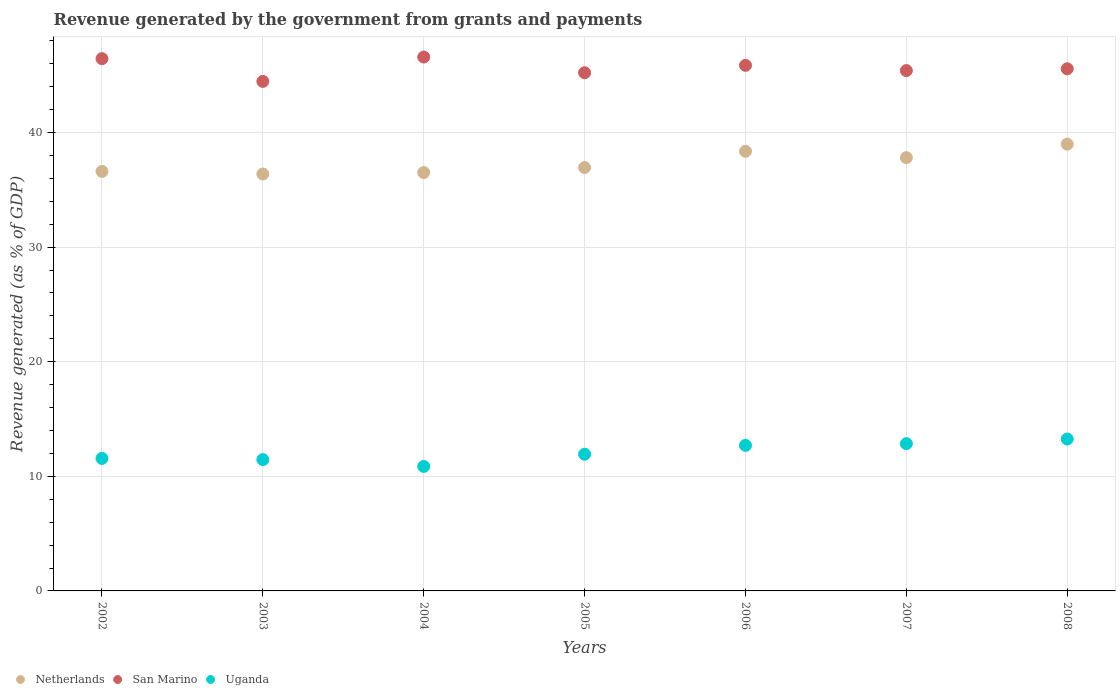How many different coloured dotlines are there?
Provide a short and direct response. 3. What is the revenue generated by the government in Netherlands in 2006?
Your response must be concise. 38.36. Across all years, what is the maximum revenue generated by the government in Netherlands?
Offer a terse response. 38.99. Across all years, what is the minimum revenue generated by the government in San Marino?
Your answer should be very brief. 44.46. In which year was the revenue generated by the government in San Marino minimum?
Make the answer very short. 2003. What is the total revenue generated by the government in San Marino in the graph?
Ensure brevity in your answer.  319.54. What is the difference between the revenue generated by the government in Netherlands in 2004 and that in 2006?
Provide a succinct answer. -1.86. What is the difference between the revenue generated by the government in San Marino in 2004 and the revenue generated by the government in Uganda in 2003?
Your response must be concise. 35.13. What is the average revenue generated by the government in San Marino per year?
Keep it short and to the point. 45.65. In the year 2004, what is the difference between the revenue generated by the government in Uganda and revenue generated by the government in Netherlands?
Keep it short and to the point. -25.64. In how many years, is the revenue generated by the government in Netherlands greater than 6 %?
Ensure brevity in your answer.  7. What is the ratio of the revenue generated by the government in Netherlands in 2004 to that in 2005?
Provide a short and direct response. 0.99. Is the revenue generated by the government in Uganda in 2004 less than that in 2007?
Give a very brief answer. Yes. What is the difference between the highest and the second highest revenue generated by the government in Uganda?
Provide a short and direct response. 0.4. What is the difference between the highest and the lowest revenue generated by the government in Netherlands?
Your answer should be compact. 2.61. In how many years, is the revenue generated by the government in Uganda greater than the average revenue generated by the government in Uganda taken over all years?
Provide a succinct answer. 3. Is the sum of the revenue generated by the government in San Marino in 2003 and 2007 greater than the maximum revenue generated by the government in Uganda across all years?
Your answer should be very brief. Yes. Is the revenue generated by the government in Netherlands strictly greater than the revenue generated by the government in San Marino over the years?
Make the answer very short. No. Does the graph contain any zero values?
Keep it short and to the point. No. Where does the legend appear in the graph?
Give a very brief answer. Bottom left. How many legend labels are there?
Keep it short and to the point. 3. What is the title of the graph?
Keep it short and to the point. Revenue generated by the government from grants and payments. Does "Bhutan" appear as one of the legend labels in the graph?
Keep it short and to the point. No. What is the label or title of the X-axis?
Your response must be concise. Years. What is the label or title of the Y-axis?
Offer a terse response. Revenue generated (as % of GDP). What is the Revenue generated (as % of GDP) of Netherlands in 2002?
Make the answer very short. 36.61. What is the Revenue generated (as % of GDP) in San Marino in 2002?
Offer a terse response. 46.45. What is the Revenue generated (as % of GDP) of Uganda in 2002?
Give a very brief answer. 11.56. What is the Revenue generated (as % of GDP) of Netherlands in 2003?
Offer a very short reply. 36.38. What is the Revenue generated (as % of GDP) of San Marino in 2003?
Keep it short and to the point. 44.46. What is the Revenue generated (as % of GDP) of Uganda in 2003?
Give a very brief answer. 11.46. What is the Revenue generated (as % of GDP) of Netherlands in 2004?
Your answer should be compact. 36.51. What is the Revenue generated (as % of GDP) in San Marino in 2004?
Offer a terse response. 46.59. What is the Revenue generated (as % of GDP) of Uganda in 2004?
Offer a terse response. 10.87. What is the Revenue generated (as % of GDP) of Netherlands in 2005?
Ensure brevity in your answer.  36.95. What is the Revenue generated (as % of GDP) in San Marino in 2005?
Your response must be concise. 45.22. What is the Revenue generated (as % of GDP) in Uganda in 2005?
Offer a very short reply. 11.93. What is the Revenue generated (as % of GDP) of Netherlands in 2006?
Your answer should be compact. 38.36. What is the Revenue generated (as % of GDP) in San Marino in 2006?
Make the answer very short. 45.86. What is the Revenue generated (as % of GDP) of Uganda in 2006?
Your answer should be very brief. 12.7. What is the Revenue generated (as % of GDP) in Netherlands in 2007?
Make the answer very short. 37.81. What is the Revenue generated (as % of GDP) of San Marino in 2007?
Provide a short and direct response. 45.4. What is the Revenue generated (as % of GDP) of Uganda in 2007?
Keep it short and to the point. 12.85. What is the Revenue generated (as % of GDP) in Netherlands in 2008?
Ensure brevity in your answer.  38.99. What is the Revenue generated (as % of GDP) in San Marino in 2008?
Your answer should be very brief. 45.56. What is the Revenue generated (as % of GDP) in Uganda in 2008?
Your answer should be compact. 13.25. Across all years, what is the maximum Revenue generated (as % of GDP) of Netherlands?
Provide a succinct answer. 38.99. Across all years, what is the maximum Revenue generated (as % of GDP) in San Marino?
Offer a very short reply. 46.59. Across all years, what is the maximum Revenue generated (as % of GDP) of Uganda?
Offer a very short reply. 13.25. Across all years, what is the minimum Revenue generated (as % of GDP) of Netherlands?
Provide a short and direct response. 36.38. Across all years, what is the minimum Revenue generated (as % of GDP) in San Marino?
Give a very brief answer. 44.46. Across all years, what is the minimum Revenue generated (as % of GDP) of Uganda?
Keep it short and to the point. 10.87. What is the total Revenue generated (as % of GDP) in Netherlands in the graph?
Make the answer very short. 261.6. What is the total Revenue generated (as % of GDP) of San Marino in the graph?
Ensure brevity in your answer.  319.54. What is the total Revenue generated (as % of GDP) of Uganda in the graph?
Provide a succinct answer. 84.62. What is the difference between the Revenue generated (as % of GDP) in Netherlands in 2002 and that in 2003?
Keep it short and to the point. 0.23. What is the difference between the Revenue generated (as % of GDP) in San Marino in 2002 and that in 2003?
Provide a succinct answer. 1.98. What is the difference between the Revenue generated (as % of GDP) in Uganda in 2002 and that in 2003?
Your answer should be very brief. 0.1. What is the difference between the Revenue generated (as % of GDP) in Netherlands in 2002 and that in 2004?
Provide a succinct answer. 0.1. What is the difference between the Revenue generated (as % of GDP) of San Marino in 2002 and that in 2004?
Offer a very short reply. -0.14. What is the difference between the Revenue generated (as % of GDP) of Uganda in 2002 and that in 2004?
Provide a succinct answer. 0.7. What is the difference between the Revenue generated (as % of GDP) of Netherlands in 2002 and that in 2005?
Offer a very short reply. -0.34. What is the difference between the Revenue generated (as % of GDP) in San Marino in 2002 and that in 2005?
Keep it short and to the point. 1.23. What is the difference between the Revenue generated (as % of GDP) of Uganda in 2002 and that in 2005?
Offer a terse response. -0.36. What is the difference between the Revenue generated (as % of GDP) of Netherlands in 2002 and that in 2006?
Keep it short and to the point. -1.75. What is the difference between the Revenue generated (as % of GDP) of San Marino in 2002 and that in 2006?
Your answer should be compact. 0.58. What is the difference between the Revenue generated (as % of GDP) of Uganda in 2002 and that in 2006?
Give a very brief answer. -1.14. What is the difference between the Revenue generated (as % of GDP) of Netherlands in 2002 and that in 2007?
Make the answer very short. -1.2. What is the difference between the Revenue generated (as % of GDP) of San Marino in 2002 and that in 2007?
Offer a very short reply. 1.04. What is the difference between the Revenue generated (as % of GDP) in Uganda in 2002 and that in 2007?
Offer a terse response. -1.29. What is the difference between the Revenue generated (as % of GDP) of Netherlands in 2002 and that in 2008?
Provide a succinct answer. -2.38. What is the difference between the Revenue generated (as % of GDP) in San Marino in 2002 and that in 2008?
Provide a short and direct response. 0.89. What is the difference between the Revenue generated (as % of GDP) of Uganda in 2002 and that in 2008?
Provide a succinct answer. -1.69. What is the difference between the Revenue generated (as % of GDP) in Netherlands in 2003 and that in 2004?
Make the answer very short. -0.13. What is the difference between the Revenue generated (as % of GDP) of San Marino in 2003 and that in 2004?
Offer a very short reply. -2.12. What is the difference between the Revenue generated (as % of GDP) in Uganda in 2003 and that in 2004?
Provide a succinct answer. 0.59. What is the difference between the Revenue generated (as % of GDP) in Netherlands in 2003 and that in 2005?
Your answer should be very brief. -0.57. What is the difference between the Revenue generated (as % of GDP) of San Marino in 2003 and that in 2005?
Your answer should be compact. -0.76. What is the difference between the Revenue generated (as % of GDP) in Uganda in 2003 and that in 2005?
Ensure brevity in your answer.  -0.47. What is the difference between the Revenue generated (as % of GDP) in Netherlands in 2003 and that in 2006?
Offer a very short reply. -1.98. What is the difference between the Revenue generated (as % of GDP) in San Marino in 2003 and that in 2006?
Offer a terse response. -1.4. What is the difference between the Revenue generated (as % of GDP) in Uganda in 2003 and that in 2006?
Ensure brevity in your answer.  -1.24. What is the difference between the Revenue generated (as % of GDP) of Netherlands in 2003 and that in 2007?
Your answer should be compact. -1.43. What is the difference between the Revenue generated (as % of GDP) of San Marino in 2003 and that in 2007?
Your answer should be very brief. -0.94. What is the difference between the Revenue generated (as % of GDP) in Uganda in 2003 and that in 2007?
Your response must be concise. -1.39. What is the difference between the Revenue generated (as % of GDP) of Netherlands in 2003 and that in 2008?
Provide a short and direct response. -2.61. What is the difference between the Revenue generated (as % of GDP) in San Marino in 2003 and that in 2008?
Your response must be concise. -1.1. What is the difference between the Revenue generated (as % of GDP) of Uganda in 2003 and that in 2008?
Make the answer very short. -1.79. What is the difference between the Revenue generated (as % of GDP) in Netherlands in 2004 and that in 2005?
Give a very brief answer. -0.44. What is the difference between the Revenue generated (as % of GDP) in San Marino in 2004 and that in 2005?
Provide a short and direct response. 1.37. What is the difference between the Revenue generated (as % of GDP) of Uganda in 2004 and that in 2005?
Your answer should be compact. -1.06. What is the difference between the Revenue generated (as % of GDP) in Netherlands in 2004 and that in 2006?
Provide a short and direct response. -1.86. What is the difference between the Revenue generated (as % of GDP) of San Marino in 2004 and that in 2006?
Your answer should be very brief. 0.72. What is the difference between the Revenue generated (as % of GDP) in Uganda in 2004 and that in 2006?
Ensure brevity in your answer.  -1.84. What is the difference between the Revenue generated (as % of GDP) in Netherlands in 2004 and that in 2007?
Give a very brief answer. -1.3. What is the difference between the Revenue generated (as % of GDP) in San Marino in 2004 and that in 2007?
Make the answer very short. 1.18. What is the difference between the Revenue generated (as % of GDP) of Uganda in 2004 and that in 2007?
Keep it short and to the point. -1.98. What is the difference between the Revenue generated (as % of GDP) in Netherlands in 2004 and that in 2008?
Make the answer very short. -2.48. What is the difference between the Revenue generated (as % of GDP) in San Marino in 2004 and that in 2008?
Provide a succinct answer. 1.03. What is the difference between the Revenue generated (as % of GDP) of Uganda in 2004 and that in 2008?
Offer a terse response. -2.39. What is the difference between the Revenue generated (as % of GDP) of Netherlands in 2005 and that in 2006?
Make the answer very short. -1.42. What is the difference between the Revenue generated (as % of GDP) of San Marino in 2005 and that in 2006?
Give a very brief answer. -0.64. What is the difference between the Revenue generated (as % of GDP) in Uganda in 2005 and that in 2006?
Offer a terse response. -0.78. What is the difference between the Revenue generated (as % of GDP) in Netherlands in 2005 and that in 2007?
Offer a very short reply. -0.86. What is the difference between the Revenue generated (as % of GDP) in San Marino in 2005 and that in 2007?
Provide a short and direct response. -0.19. What is the difference between the Revenue generated (as % of GDP) in Uganda in 2005 and that in 2007?
Provide a succinct answer. -0.92. What is the difference between the Revenue generated (as % of GDP) in Netherlands in 2005 and that in 2008?
Offer a terse response. -2.04. What is the difference between the Revenue generated (as % of GDP) of San Marino in 2005 and that in 2008?
Your answer should be compact. -0.34. What is the difference between the Revenue generated (as % of GDP) in Uganda in 2005 and that in 2008?
Provide a succinct answer. -1.33. What is the difference between the Revenue generated (as % of GDP) in Netherlands in 2006 and that in 2007?
Ensure brevity in your answer.  0.56. What is the difference between the Revenue generated (as % of GDP) of San Marino in 2006 and that in 2007?
Give a very brief answer. 0.46. What is the difference between the Revenue generated (as % of GDP) of Uganda in 2006 and that in 2007?
Provide a succinct answer. -0.15. What is the difference between the Revenue generated (as % of GDP) in Netherlands in 2006 and that in 2008?
Offer a very short reply. -0.62. What is the difference between the Revenue generated (as % of GDP) in San Marino in 2006 and that in 2008?
Make the answer very short. 0.3. What is the difference between the Revenue generated (as % of GDP) in Uganda in 2006 and that in 2008?
Ensure brevity in your answer.  -0.55. What is the difference between the Revenue generated (as % of GDP) in Netherlands in 2007 and that in 2008?
Offer a terse response. -1.18. What is the difference between the Revenue generated (as % of GDP) of San Marino in 2007 and that in 2008?
Ensure brevity in your answer.  -0.16. What is the difference between the Revenue generated (as % of GDP) of Uganda in 2007 and that in 2008?
Your answer should be compact. -0.4. What is the difference between the Revenue generated (as % of GDP) of Netherlands in 2002 and the Revenue generated (as % of GDP) of San Marino in 2003?
Provide a short and direct response. -7.85. What is the difference between the Revenue generated (as % of GDP) in Netherlands in 2002 and the Revenue generated (as % of GDP) in Uganda in 2003?
Offer a very short reply. 25.15. What is the difference between the Revenue generated (as % of GDP) in San Marino in 2002 and the Revenue generated (as % of GDP) in Uganda in 2003?
Provide a succinct answer. 34.99. What is the difference between the Revenue generated (as % of GDP) in Netherlands in 2002 and the Revenue generated (as % of GDP) in San Marino in 2004?
Provide a short and direct response. -9.98. What is the difference between the Revenue generated (as % of GDP) in Netherlands in 2002 and the Revenue generated (as % of GDP) in Uganda in 2004?
Ensure brevity in your answer.  25.74. What is the difference between the Revenue generated (as % of GDP) in San Marino in 2002 and the Revenue generated (as % of GDP) in Uganda in 2004?
Offer a very short reply. 35.58. What is the difference between the Revenue generated (as % of GDP) of Netherlands in 2002 and the Revenue generated (as % of GDP) of San Marino in 2005?
Your response must be concise. -8.61. What is the difference between the Revenue generated (as % of GDP) of Netherlands in 2002 and the Revenue generated (as % of GDP) of Uganda in 2005?
Keep it short and to the point. 24.68. What is the difference between the Revenue generated (as % of GDP) of San Marino in 2002 and the Revenue generated (as % of GDP) of Uganda in 2005?
Your answer should be very brief. 34.52. What is the difference between the Revenue generated (as % of GDP) of Netherlands in 2002 and the Revenue generated (as % of GDP) of San Marino in 2006?
Your response must be concise. -9.25. What is the difference between the Revenue generated (as % of GDP) of Netherlands in 2002 and the Revenue generated (as % of GDP) of Uganda in 2006?
Your response must be concise. 23.91. What is the difference between the Revenue generated (as % of GDP) in San Marino in 2002 and the Revenue generated (as % of GDP) in Uganda in 2006?
Provide a succinct answer. 33.74. What is the difference between the Revenue generated (as % of GDP) of Netherlands in 2002 and the Revenue generated (as % of GDP) of San Marino in 2007?
Provide a short and direct response. -8.79. What is the difference between the Revenue generated (as % of GDP) of Netherlands in 2002 and the Revenue generated (as % of GDP) of Uganda in 2007?
Keep it short and to the point. 23.76. What is the difference between the Revenue generated (as % of GDP) of San Marino in 2002 and the Revenue generated (as % of GDP) of Uganda in 2007?
Make the answer very short. 33.6. What is the difference between the Revenue generated (as % of GDP) of Netherlands in 2002 and the Revenue generated (as % of GDP) of San Marino in 2008?
Ensure brevity in your answer.  -8.95. What is the difference between the Revenue generated (as % of GDP) of Netherlands in 2002 and the Revenue generated (as % of GDP) of Uganda in 2008?
Keep it short and to the point. 23.36. What is the difference between the Revenue generated (as % of GDP) in San Marino in 2002 and the Revenue generated (as % of GDP) in Uganda in 2008?
Ensure brevity in your answer.  33.19. What is the difference between the Revenue generated (as % of GDP) in Netherlands in 2003 and the Revenue generated (as % of GDP) in San Marino in 2004?
Your answer should be very brief. -10.21. What is the difference between the Revenue generated (as % of GDP) of Netherlands in 2003 and the Revenue generated (as % of GDP) of Uganda in 2004?
Make the answer very short. 25.51. What is the difference between the Revenue generated (as % of GDP) in San Marino in 2003 and the Revenue generated (as % of GDP) in Uganda in 2004?
Provide a short and direct response. 33.6. What is the difference between the Revenue generated (as % of GDP) of Netherlands in 2003 and the Revenue generated (as % of GDP) of San Marino in 2005?
Keep it short and to the point. -8.84. What is the difference between the Revenue generated (as % of GDP) in Netherlands in 2003 and the Revenue generated (as % of GDP) in Uganda in 2005?
Your answer should be compact. 24.45. What is the difference between the Revenue generated (as % of GDP) of San Marino in 2003 and the Revenue generated (as % of GDP) of Uganda in 2005?
Ensure brevity in your answer.  32.54. What is the difference between the Revenue generated (as % of GDP) of Netherlands in 2003 and the Revenue generated (as % of GDP) of San Marino in 2006?
Make the answer very short. -9.48. What is the difference between the Revenue generated (as % of GDP) of Netherlands in 2003 and the Revenue generated (as % of GDP) of Uganda in 2006?
Offer a terse response. 23.68. What is the difference between the Revenue generated (as % of GDP) in San Marino in 2003 and the Revenue generated (as % of GDP) in Uganda in 2006?
Keep it short and to the point. 31.76. What is the difference between the Revenue generated (as % of GDP) in Netherlands in 2003 and the Revenue generated (as % of GDP) in San Marino in 2007?
Ensure brevity in your answer.  -9.02. What is the difference between the Revenue generated (as % of GDP) of Netherlands in 2003 and the Revenue generated (as % of GDP) of Uganda in 2007?
Offer a terse response. 23.53. What is the difference between the Revenue generated (as % of GDP) in San Marino in 2003 and the Revenue generated (as % of GDP) in Uganda in 2007?
Your answer should be very brief. 31.61. What is the difference between the Revenue generated (as % of GDP) in Netherlands in 2003 and the Revenue generated (as % of GDP) in San Marino in 2008?
Offer a very short reply. -9.18. What is the difference between the Revenue generated (as % of GDP) of Netherlands in 2003 and the Revenue generated (as % of GDP) of Uganda in 2008?
Ensure brevity in your answer.  23.13. What is the difference between the Revenue generated (as % of GDP) of San Marino in 2003 and the Revenue generated (as % of GDP) of Uganda in 2008?
Give a very brief answer. 31.21. What is the difference between the Revenue generated (as % of GDP) of Netherlands in 2004 and the Revenue generated (as % of GDP) of San Marino in 2005?
Provide a succinct answer. -8.71. What is the difference between the Revenue generated (as % of GDP) in Netherlands in 2004 and the Revenue generated (as % of GDP) in Uganda in 2005?
Offer a very short reply. 24.58. What is the difference between the Revenue generated (as % of GDP) in San Marino in 2004 and the Revenue generated (as % of GDP) in Uganda in 2005?
Give a very brief answer. 34.66. What is the difference between the Revenue generated (as % of GDP) in Netherlands in 2004 and the Revenue generated (as % of GDP) in San Marino in 2006?
Offer a terse response. -9.36. What is the difference between the Revenue generated (as % of GDP) in Netherlands in 2004 and the Revenue generated (as % of GDP) in Uganda in 2006?
Your answer should be very brief. 23.8. What is the difference between the Revenue generated (as % of GDP) in San Marino in 2004 and the Revenue generated (as % of GDP) in Uganda in 2006?
Offer a terse response. 33.88. What is the difference between the Revenue generated (as % of GDP) in Netherlands in 2004 and the Revenue generated (as % of GDP) in San Marino in 2007?
Make the answer very short. -8.9. What is the difference between the Revenue generated (as % of GDP) of Netherlands in 2004 and the Revenue generated (as % of GDP) of Uganda in 2007?
Make the answer very short. 23.66. What is the difference between the Revenue generated (as % of GDP) in San Marino in 2004 and the Revenue generated (as % of GDP) in Uganda in 2007?
Make the answer very short. 33.74. What is the difference between the Revenue generated (as % of GDP) in Netherlands in 2004 and the Revenue generated (as % of GDP) in San Marino in 2008?
Provide a succinct answer. -9.05. What is the difference between the Revenue generated (as % of GDP) of Netherlands in 2004 and the Revenue generated (as % of GDP) of Uganda in 2008?
Keep it short and to the point. 23.25. What is the difference between the Revenue generated (as % of GDP) of San Marino in 2004 and the Revenue generated (as % of GDP) of Uganda in 2008?
Give a very brief answer. 33.33. What is the difference between the Revenue generated (as % of GDP) of Netherlands in 2005 and the Revenue generated (as % of GDP) of San Marino in 2006?
Ensure brevity in your answer.  -8.92. What is the difference between the Revenue generated (as % of GDP) of Netherlands in 2005 and the Revenue generated (as % of GDP) of Uganda in 2006?
Offer a terse response. 24.24. What is the difference between the Revenue generated (as % of GDP) of San Marino in 2005 and the Revenue generated (as % of GDP) of Uganda in 2006?
Your answer should be compact. 32.52. What is the difference between the Revenue generated (as % of GDP) in Netherlands in 2005 and the Revenue generated (as % of GDP) in San Marino in 2007?
Make the answer very short. -8.46. What is the difference between the Revenue generated (as % of GDP) of Netherlands in 2005 and the Revenue generated (as % of GDP) of Uganda in 2007?
Your answer should be compact. 24.1. What is the difference between the Revenue generated (as % of GDP) of San Marino in 2005 and the Revenue generated (as % of GDP) of Uganda in 2007?
Offer a terse response. 32.37. What is the difference between the Revenue generated (as % of GDP) of Netherlands in 2005 and the Revenue generated (as % of GDP) of San Marino in 2008?
Provide a short and direct response. -8.61. What is the difference between the Revenue generated (as % of GDP) of Netherlands in 2005 and the Revenue generated (as % of GDP) of Uganda in 2008?
Ensure brevity in your answer.  23.69. What is the difference between the Revenue generated (as % of GDP) in San Marino in 2005 and the Revenue generated (as % of GDP) in Uganda in 2008?
Your response must be concise. 31.96. What is the difference between the Revenue generated (as % of GDP) of Netherlands in 2006 and the Revenue generated (as % of GDP) of San Marino in 2007?
Make the answer very short. -7.04. What is the difference between the Revenue generated (as % of GDP) of Netherlands in 2006 and the Revenue generated (as % of GDP) of Uganda in 2007?
Give a very brief answer. 25.51. What is the difference between the Revenue generated (as % of GDP) in San Marino in 2006 and the Revenue generated (as % of GDP) in Uganda in 2007?
Provide a succinct answer. 33.01. What is the difference between the Revenue generated (as % of GDP) in Netherlands in 2006 and the Revenue generated (as % of GDP) in San Marino in 2008?
Make the answer very short. -7.2. What is the difference between the Revenue generated (as % of GDP) of Netherlands in 2006 and the Revenue generated (as % of GDP) of Uganda in 2008?
Make the answer very short. 25.11. What is the difference between the Revenue generated (as % of GDP) of San Marino in 2006 and the Revenue generated (as % of GDP) of Uganda in 2008?
Keep it short and to the point. 32.61. What is the difference between the Revenue generated (as % of GDP) of Netherlands in 2007 and the Revenue generated (as % of GDP) of San Marino in 2008?
Keep it short and to the point. -7.75. What is the difference between the Revenue generated (as % of GDP) in Netherlands in 2007 and the Revenue generated (as % of GDP) in Uganda in 2008?
Offer a terse response. 24.55. What is the difference between the Revenue generated (as % of GDP) in San Marino in 2007 and the Revenue generated (as % of GDP) in Uganda in 2008?
Keep it short and to the point. 32.15. What is the average Revenue generated (as % of GDP) in Netherlands per year?
Your answer should be very brief. 37.37. What is the average Revenue generated (as % of GDP) of San Marino per year?
Keep it short and to the point. 45.65. What is the average Revenue generated (as % of GDP) in Uganda per year?
Your answer should be compact. 12.09. In the year 2002, what is the difference between the Revenue generated (as % of GDP) of Netherlands and Revenue generated (as % of GDP) of San Marino?
Offer a very short reply. -9.84. In the year 2002, what is the difference between the Revenue generated (as % of GDP) in Netherlands and Revenue generated (as % of GDP) in Uganda?
Provide a short and direct response. 25.05. In the year 2002, what is the difference between the Revenue generated (as % of GDP) of San Marino and Revenue generated (as % of GDP) of Uganda?
Provide a short and direct response. 34.88. In the year 2003, what is the difference between the Revenue generated (as % of GDP) of Netherlands and Revenue generated (as % of GDP) of San Marino?
Provide a succinct answer. -8.08. In the year 2003, what is the difference between the Revenue generated (as % of GDP) in Netherlands and Revenue generated (as % of GDP) in Uganda?
Your response must be concise. 24.92. In the year 2003, what is the difference between the Revenue generated (as % of GDP) in San Marino and Revenue generated (as % of GDP) in Uganda?
Your answer should be compact. 33. In the year 2004, what is the difference between the Revenue generated (as % of GDP) of Netherlands and Revenue generated (as % of GDP) of San Marino?
Provide a short and direct response. -10.08. In the year 2004, what is the difference between the Revenue generated (as % of GDP) of Netherlands and Revenue generated (as % of GDP) of Uganda?
Provide a short and direct response. 25.64. In the year 2004, what is the difference between the Revenue generated (as % of GDP) of San Marino and Revenue generated (as % of GDP) of Uganda?
Keep it short and to the point. 35.72. In the year 2005, what is the difference between the Revenue generated (as % of GDP) of Netherlands and Revenue generated (as % of GDP) of San Marino?
Your response must be concise. -8.27. In the year 2005, what is the difference between the Revenue generated (as % of GDP) of Netherlands and Revenue generated (as % of GDP) of Uganda?
Keep it short and to the point. 25.02. In the year 2005, what is the difference between the Revenue generated (as % of GDP) of San Marino and Revenue generated (as % of GDP) of Uganda?
Your answer should be compact. 33.29. In the year 2006, what is the difference between the Revenue generated (as % of GDP) in Netherlands and Revenue generated (as % of GDP) in San Marino?
Ensure brevity in your answer.  -7.5. In the year 2006, what is the difference between the Revenue generated (as % of GDP) of Netherlands and Revenue generated (as % of GDP) of Uganda?
Make the answer very short. 25.66. In the year 2006, what is the difference between the Revenue generated (as % of GDP) in San Marino and Revenue generated (as % of GDP) in Uganda?
Offer a terse response. 33.16. In the year 2007, what is the difference between the Revenue generated (as % of GDP) of Netherlands and Revenue generated (as % of GDP) of San Marino?
Keep it short and to the point. -7.6. In the year 2007, what is the difference between the Revenue generated (as % of GDP) in Netherlands and Revenue generated (as % of GDP) in Uganda?
Give a very brief answer. 24.96. In the year 2007, what is the difference between the Revenue generated (as % of GDP) of San Marino and Revenue generated (as % of GDP) of Uganda?
Make the answer very short. 32.55. In the year 2008, what is the difference between the Revenue generated (as % of GDP) in Netherlands and Revenue generated (as % of GDP) in San Marino?
Give a very brief answer. -6.57. In the year 2008, what is the difference between the Revenue generated (as % of GDP) of Netherlands and Revenue generated (as % of GDP) of Uganda?
Make the answer very short. 25.73. In the year 2008, what is the difference between the Revenue generated (as % of GDP) of San Marino and Revenue generated (as % of GDP) of Uganda?
Your answer should be compact. 32.31. What is the ratio of the Revenue generated (as % of GDP) of Netherlands in 2002 to that in 2003?
Ensure brevity in your answer.  1.01. What is the ratio of the Revenue generated (as % of GDP) of San Marino in 2002 to that in 2003?
Keep it short and to the point. 1.04. What is the ratio of the Revenue generated (as % of GDP) of Netherlands in 2002 to that in 2004?
Provide a short and direct response. 1. What is the ratio of the Revenue generated (as % of GDP) of Uganda in 2002 to that in 2004?
Keep it short and to the point. 1.06. What is the ratio of the Revenue generated (as % of GDP) in Netherlands in 2002 to that in 2005?
Offer a very short reply. 0.99. What is the ratio of the Revenue generated (as % of GDP) of San Marino in 2002 to that in 2005?
Offer a terse response. 1.03. What is the ratio of the Revenue generated (as % of GDP) in Uganda in 2002 to that in 2005?
Ensure brevity in your answer.  0.97. What is the ratio of the Revenue generated (as % of GDP) of Netherlands in 2002 to that in 2006?
Make the answer very short. 0.95. What is the ratio of the Revenue generated (as % of GDP) of San Marino in 2002 to that in 2006?
Offer a very short reply. 1.01. What is the ratio of the Revenue generated (as % of GDP) in Uganda in 2002 to that in 2006?
Provide a short and direct response. 0.91. What is the ratio of the Revenue generated (as % of GDP) in Netherlands in 2002 to that in 2007?
Provide a succinct answer. 0.97. What is the ratio of the Revenue generated (as % of GDP) of San Marino in 2002 to that in 2007?
Your response must be concise. 1.02. What is the ratio of the Revenue generated (as % of GDP) of Uganda in 2002 to that in 2007?
Your answer should be very brief. 0.9. What is the ratio of the Revenue generated (as % of GDP) in Netherlands in 2002 to that in 2008?
Make the answer very short. 0.94. What is the ratio of the Revenue generated (as % of GDP) in San Marino in 2002 to that in 2008?
Your answer should be compact. 1.02. What is the ratio of the Revenue generated (as % of GDP) of Uganda in 2002 to that in 2008?
Give a very brief answer. 0.87. What is the ratio of the Revenue generated (as % of GDP) in Netherlands in 2003 to that in 2004?
Offer a terse response. 1. What is the ratio of the Revenue generated (as % of GDP) of San Marino in 2003 to that in 2004?
Keep it short and to the point. 0.95. What is the ratio of the Revenue generated (as % of GDP) in Uganda in 2003 to that in 2004?
Offer a very short reply. 1.05. What is the ratio of the Revenue generated (as % of GDP) in Netherlands in 2003 to that in 2005?
Provide a succinct answer. 0.98. What is the ratio of the Revenue generated (as % of GDP) in San Marino in 2003 to that in 2005?
Give a very brief answer. 0.98. What is the ratio of the Revenue generated (as % of GDP) of Uganda in 2003 to that in 2005?
Make the answer very short. 0.96. What is the ratio of the Revenue generated (as % of GDP) in Netherlands in 2003 to that in 2006?
Ensure brevity in your answer.  0.95. What is the ratio of the Revenue generated (as % of GDP) of San Marino in 2003 to that in 2006?
Provide a succinct answer. 0.97. What is the ratio of the Revenue generated (as % of GDP) of Uganda in 2003 to that in 2006?
Your answer should be compact. 0.9. What is the ratio of the Revenue generated (as % of GDP) of Netherlands in 2003 to that in 2007?
Provide a succinct answer. 0.96. What is the ratio of the Revenue generated (as % of GDP) in San Marino in 2003 to that in 2007?
Your answer should be compact. 0.98. What is the ratio of the Revenue generated (as % of GDP) of Uganda in 2003 to that in 2007?
Make the answer very short. 0.89. What is the ratio of the Revenue generated (as % of GDP) in Netherlands in 2003 to that in 2008?
Your answer should be very brief. 0.93. What is the ratio of the Revenue generated (as % of GDP) of San Marino in 2003 to that in 2008?
Offer a very short reply. 0.98. What is the ratio of the Revenue generated (as % of GDP) in Uganda in 2003 to that in 2008?
Provide a succinct answer. 0.86. What is the ratio of the Revenue generated (as % of GDP) in Netherlands in 2004 to that in 2005?
Provide a short and direct response. 0.99. What is the ratio of the Revenue generated (as % of GDP) of San Marino in 2004 to that in 2005?
Ensure brevity in your answer.  1.03. What is the ratio of the Revenue generated (as % of GDP) of Uganda in 2004 to that in 2005?
Offer a terse response. 0.91. What is the ratio of the Revenue generated (as % of GDP) of Netherlands in 2004 to that in 2006?
Provide a short and direct response. 0.95. What is the ratio of the Revenue generated (as % of GDP) in San Marino in 2004 to that in 2006?
Your answer should be very brief. 1.02. What is the ratio of the Revenue generated (as % of GDP) of Uganda in 2004 to that in 2006?
Keep it short and to the point. 0.86. What is the ratio of the Revenue generated (as % of GDP) of Netherlands in 2004 to that in 2007?
Give a very brief answer. 0.97. What is the ratio of the Revenue generated (as % of GDP) in San Marino in 2004 to that in 2007?
Keep it short and to the point. 1.03. What is the ratio of the Revenue generated (as % of GDP) in Uganda in 2004 to that in 2007?
Your answer should be compact. 0.85. What is the ratio of the Revenue generated (as % of GDP) of Netherlands in 2004 to that in 2008?
Your answer should be very brief. 0.94. What is the ratio of the Revenue generated (as % of GDP) of San Marino in 2004 to that in 2008?
Keep it short and to the point. 1.02. What is the ratio of the Revenue generated (as % of GDP) in Uganda in 2004 to that in 2008?
Make the answer very short. 0.82. What is the ratio of the Revenue generated (as % of GDP) in Netherlands in 2005 to that in 2006?
Your answer should be compact. 0.96. What is the ratio of the Revenue generated (as % of GDP) of Uganda in 2005 to that in 2006?
Make the answer very short. 0.94. What is the ratio of the Revenue generated (as % of GDP) of Netherlands in 2005 to that in 2007?
Your answer should be compact. 0.98. What is the ratio of the Revenue generated (as % of GDP) in Uganda in 2005 to that in 2007?
Make the answer very short. 0.93. What is the ratio of the Revenue generated (as % of GDP) in Netherlands in 2005 to that in 2008?
Provide a succinct answer. 0.95. What is the ratio of the Revenue generated (as % of GDP) in Uganda in 2005 to that in 2008?
Keep it short and to the point. 0.9. What is the ratio of the Revenue generated (as % of GDP) in Netherlands in 2006 to that in 2007?
Offer a terse response. 1.01. What is the ratio of the Revenue generated (as % of GDP) in San Marino in 2006 to that in 2007?
Keep it short and to the point. 1.01. What is the ratio of the Revenue generated (as % of GDP) in Uganda in 2006 to that in 2007?
Provide a short and direct response. 0.99. What is the ratio of the Revenue generated (as % of GDP) in San Marino in 2006 to that in 2008?
Give a very brief answer. 1.01. What is the ratio of the Revenue generated (as % of GDP) in Uganda in 2006 to that in 2008?
Keep it short and to the point. 0.96. What is the ratio of the Revenue generated (as % of GDP) in Netherlands in 2007 to that in 2008?
Make the answer very short. 0.97. What is the ratio of the Revenue generated (as % of GDP) of Uganda in 2007 to that in 2008?
Keep it short and to the point. 0.97. What is the difference between the highest and the second highest Revenue generated (as % of GDP) in Netherlands?
Make the answer very short. 0.62. What is the difference between the highest and the second highest Revenue generated (as % of GDP) in San Marino?
Make the answer very short. 0.14. What is the difference between the highest and the second highest Revenue generated (as % of GDP) of Uganda?
Offer a very short reply. 0.4. What is the difference between the highest and the lowest Revenue generated (as % of GDP) in Netherlands?
Provide a succinct answer. 2.61. What is the difference between the highest and the lowest Revenue generated (as % of GDP) in San Marino?
Your answer should be very brief. 2.12. What is the difference between the highest and the lowest Revenue generated (as % of GDP) in Uganda?
Make the answer very short. 2.39. 